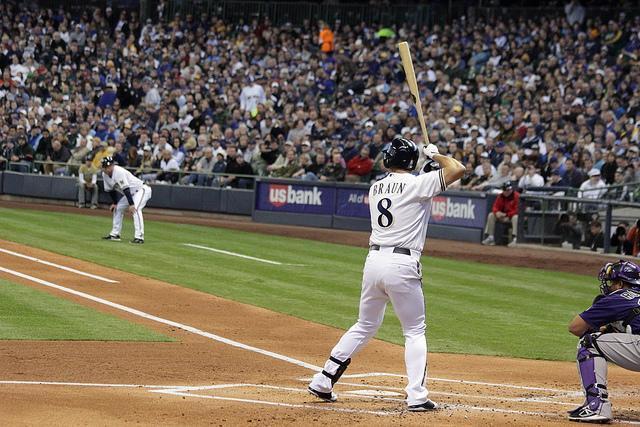How many people can be seen?
Give a very brief answer. 4. 